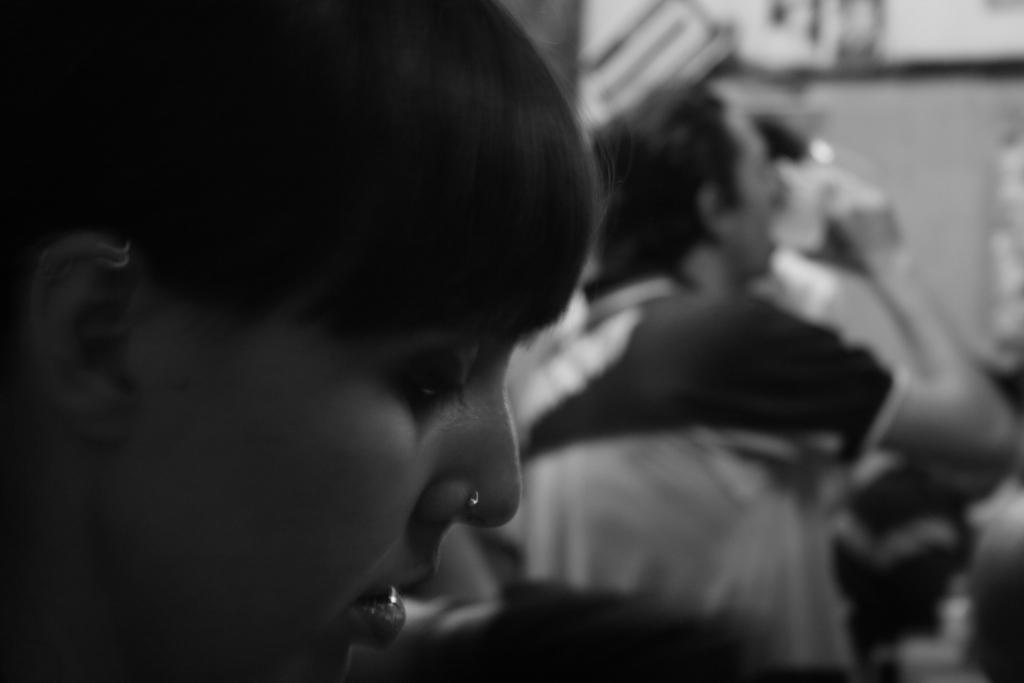Who or what is present in the image? There are people in the image. What is the background of the image? There is a wall in the image. Can you describe the lighting in the image? The image appears to be slightly dark. What degree does the grandfather hold in the image? There is no mention of a grandfather or a degree in the image. 